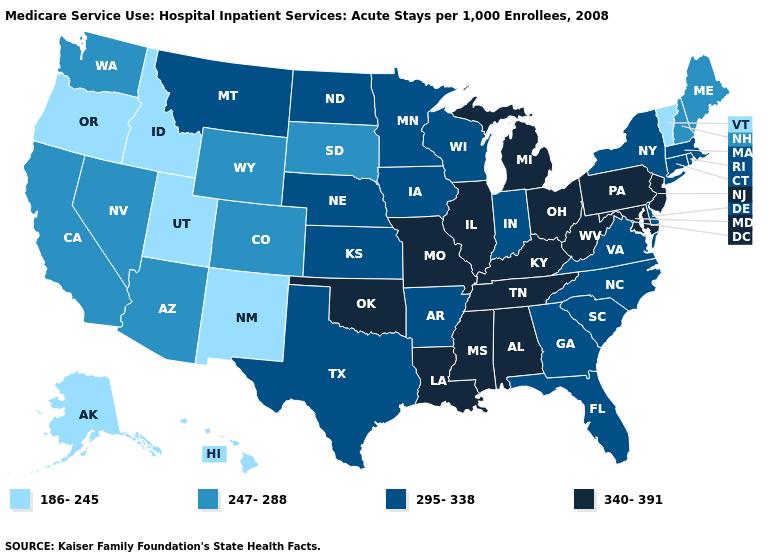Does Montana have the highest value in the West?
Write a very short answer. Yes. What is the lowest value in states that border Utah?
Answer briefly. 186-245. What is the value of Hawaii?
Concise answer only. 186-245. What is the lowest value in states that border Texas?
Quick response, please. 186-245. Which states hav the highest value in the Northeast?
Write a very short answer. New Jersey, Pennsylvania. What is the value of Massachusetts?
Keep it brief. 295-338. Name the states that have a value in the range 295-338?
Be succinct. Arkansas, Connecticut, Delaware, Florida, Georgia, Indiana, Iowa, Kansas, Massachusetts, Minnesota, Montana, Nebraska, New York, North Carolina, North Dakota, Rhode Island, South Carolina, Texas, Virginia, Wisconsin. What is the value of Iowa?
Quick response, please. 295-338. What is the value of Hawaii?
Be succinct. 186-245. What is the lowest value in the West?
Short answer required. 186-245. Does Michigan have the highest value in the MidWest?
Short answer required. Yes. Does the first symbol in the legend represent the smallest category?
Short answer required. Yes. Among the states that border New Hampshire , does Vermont have the highest value?
Give a very brief answer. No. Name the states that have a value in the range 247-288?
Be succinct. Arizona, California, Colorado, Maine, Nevada, New Hampshire, South Dakota, Washington, Wyoming. 